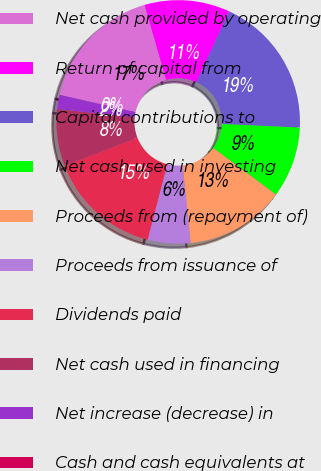Convert chart to OTSL. <chart><loc_0><loc_0><loc_500><loc_500><pie_chart><fcel>Net cash provided by operating<fcel>Return of capital from<fcel>Capital contributions to<fcel>Net cash used in investing<fcel>Proceeds from (repayment of)<fcel>Proceeds from issuance of<fcel>Dividends paid<fcel>Net cash used in financing<fcel>Net increase (decrease) in<fcel>Cash and cash equivalents at<nl><fcel>16.98%<fcel>11.32%<fcel>18.87%<fcel>9.43%<fcel>13.21%<fcel>5.66%<fcel>15.09%<fcel>7.55%<fcel>1.89%<fcel>0.0%<nl></chart> 